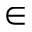<formula> <loc_0><loc_0><loc_500><loc_500>\in</formula> 